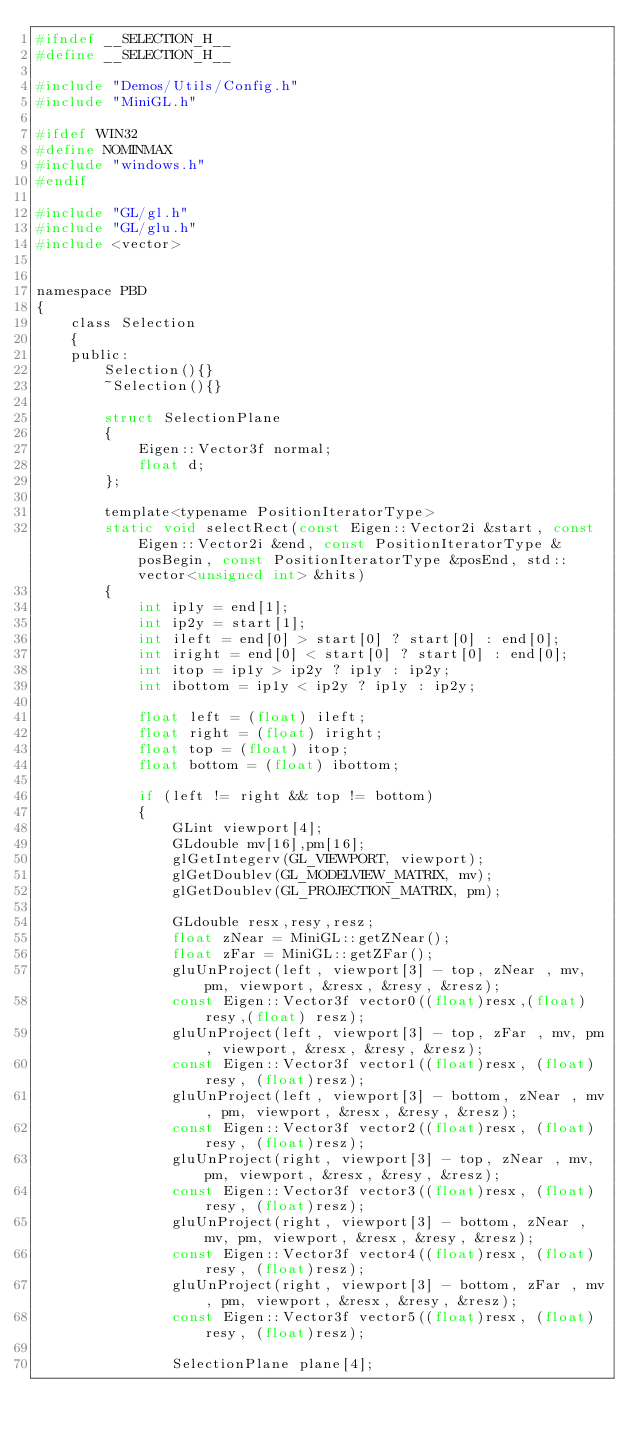Convert code to text. <code><loc_0><loc_0><loc_500><loc_500><_C_>#ifndef __SELECTION_H__
#define __SELECTION_H__

#include "Demos/Utils/Config.h"
#include "MiniGL.h"

#ifdef WIN32
#define NOMINMAX
#include "windows.h"
#endif

#include "GL/gl.h"
#include "GL/glu.h"
#include <vector>


namespace PBD
{
	class Selection
	{
	public:
		Selection(){}
		~Selection(){}

		struct SelectionPlane
		{
			Eigen::Vector3f normal;
			float d;
		};

		template<typename PositionIteratorType>
		static void selectRect(const Eigen::Vector2i &start, const Eigen::Vector2i &end, const PositionIteratorType &posBegin, const PositionIteratorType &posEnd, std::vector<unsigned int> &hits)
		{
			int ip1y = end[1];
			int ip2y = start[1];
			int ileft = end[0] > start[0] ?	start[0] : end[0];
			int iright = end[0] < start[0] ? start[0] : end[0];
			int itop = ip1y > ip2y ? ip1y : ip2y;
			int ibottom = ip1y < ip2y ? ip1y : ip2y;

			float left = (float) ileft;
			float right = (float) iright;
			float top = (float) itop;
			float bottom = (float) ibottom;

			if (left != right && top != bottom)
			{
				GLint viewport[4];
				GLdouble mv[16],pm[16];
				glGetIntegerv(GL_VIEWPORT, viewport);
				glGetDoublev(GL_MODELVIEW_MATRIX, mv);
				glGetDoublev(GL_PROJECTION_MATRIX, pm);

				GLdouble resx,resy,resz;
				float zNear = MiniGL::getZNear();
				float zFar = MiniGL::getZFar();
				gluUnProject(left, viewport[3] - top, zNear , mv, pm, viewport, &resx, &resy, &resz);
				const Eigen::Vector3f vector0((float)resx,(float) resy,(float) resz);
				gluUnProject(left, viewport[3] - top, zFar , mv, pm, viewport, &resx, &resy, &resz);
				const Eigen::Vector3f vector1((float)resx, (float)resy, (float)resz);
				gluUnProject(left, viewport[3] - bottom, zNear , mv, pm, viewport, &resx, &resy, &resz);
				const Eigen::Vector3f vector2((float)resx, (float)resy, (float)resz);
				gluUnProject(right, viewport[3] - top, zNear , mv, pm, viewport, &resx, &resy, &resz);
				const Eigen::Vector3f vector3((float)resx, (float)resy, (float)resz);
				gluUnProject(right, viewport[3] - bottom, zNear , mv, pm, viewport, &resx, &resy, &resz);
				const Eigen::Vector3f vector4((float)resx, (float)resy, (float)resz);
				gluUnProject(right, viewport[3] - bottom, zFar , mv, pm, viewport, &resx, &resy, &resz);
				const Eigen::Vector3f vector5((float)resx, (float)resy, (float)resz);

				SelectionPlane plane[4];</code> 